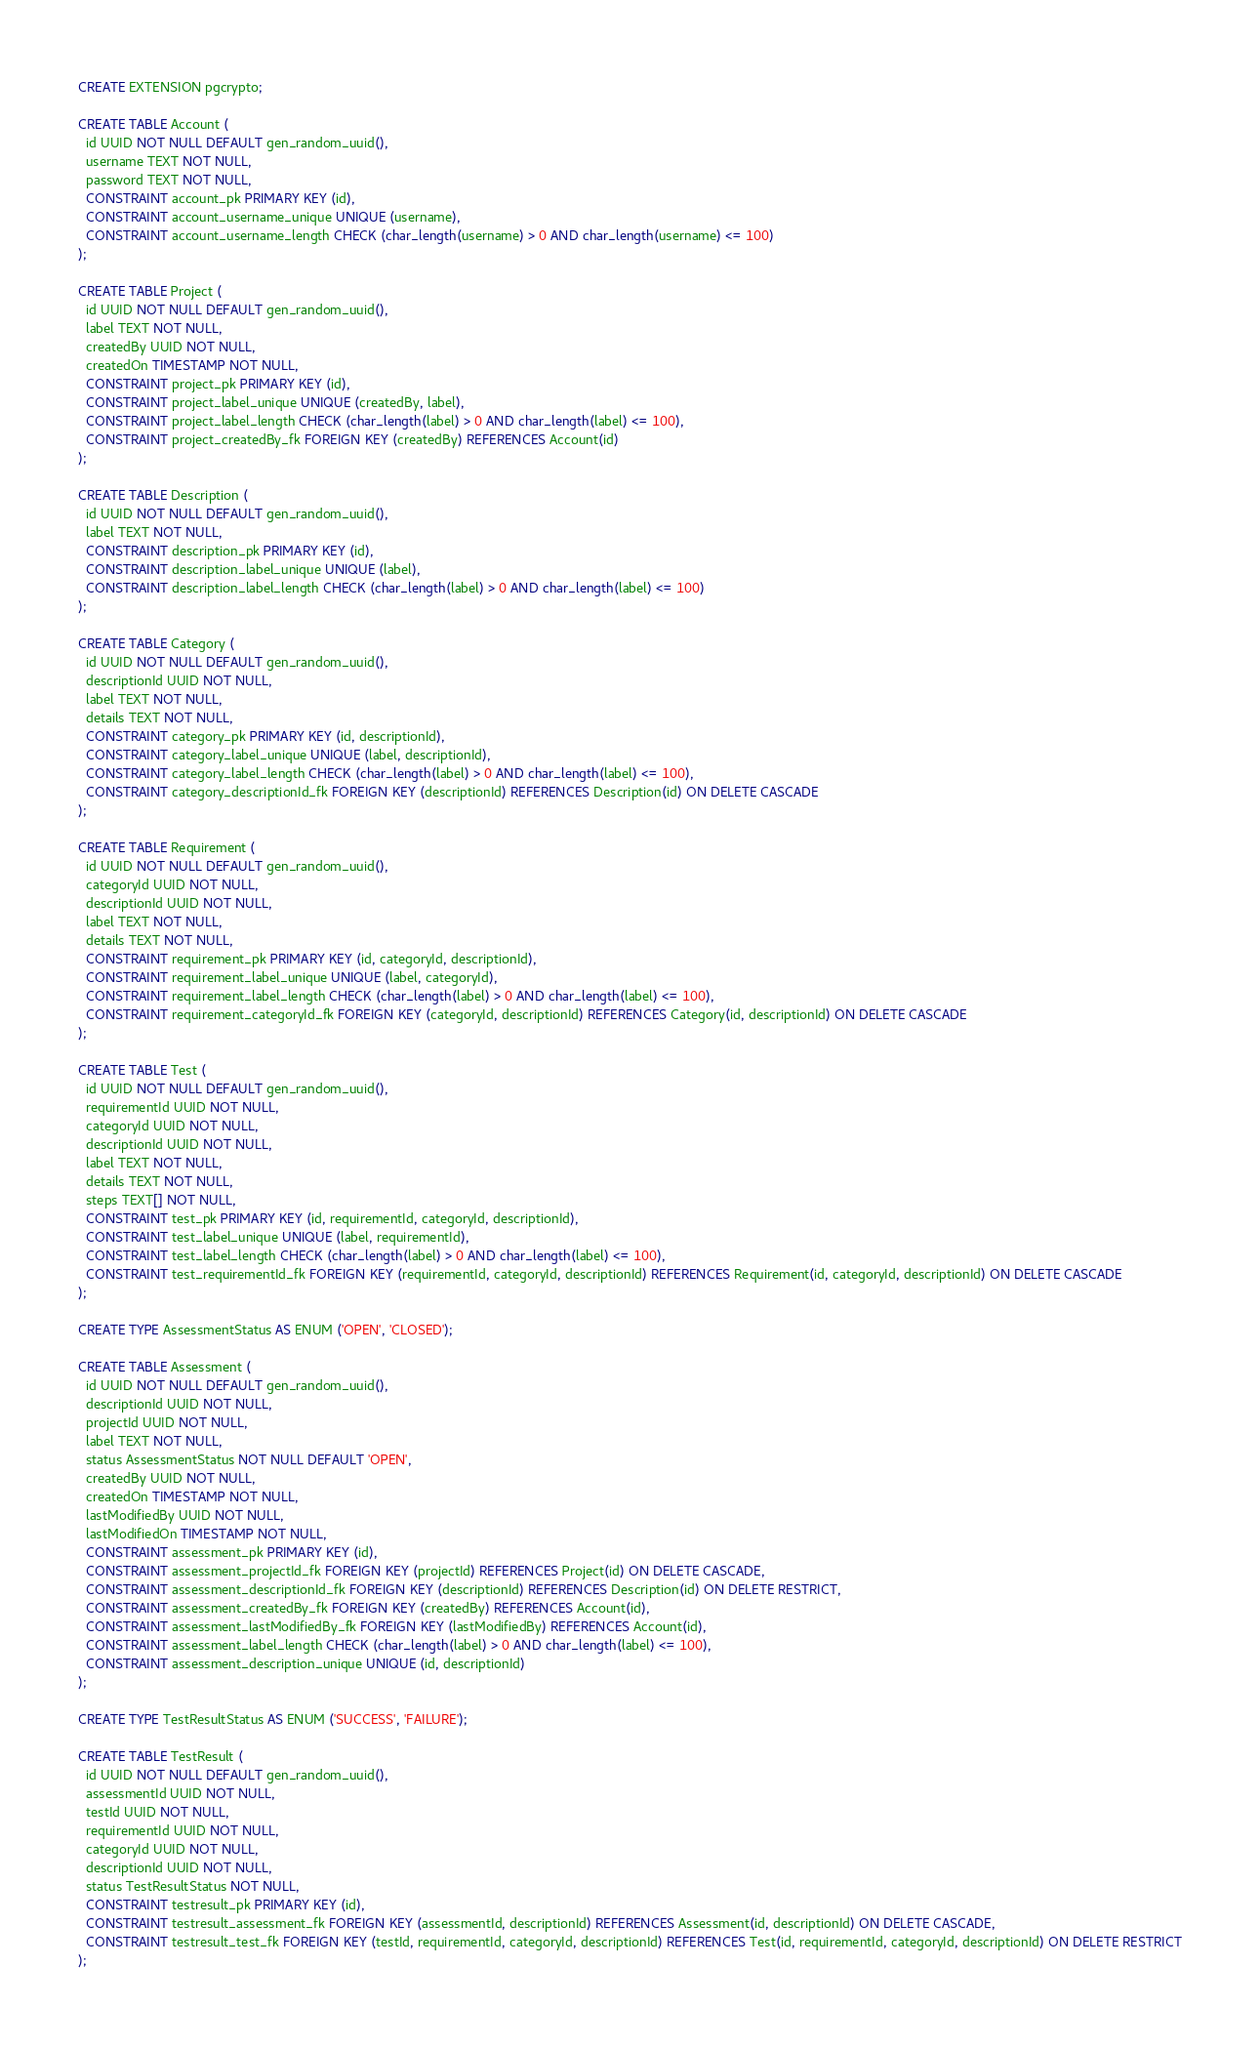Convert code to text. <code><loc_0><loc_0><loc_500><loc_500><_SQL_>CREATE EXTENSION pgcrypto;

CREATE TABLE Account (
  id UUID NOT NULL DEFAULT gen_random_uuid(),
  username TEXT NOT NULL,
  password TEXT NOT NULL,
  CONSTRAINT account_pk PRIMARY KEY (id),
  CONSTRAINT account_username_unique UNIQUE (username),
  CONSTRAINT account_username_length CHECK (char_length(username) > 0 AND char_length(username) <= 100)
);

CREATE TABLE Project (
  id UUID NOT NULL DEFAULT gen_random_uuid(),
  label TEXT NOT NULL,
  createdBy UUID NOT NULL,
  createdOn TIMESTAMP NOT NULL,
  CONSTRAINT project_pk PRIMARY KEY (id),
  CONSTRAINT project_label_unique UNIQUE (createdBy, label),
  CONSTRAINT project_label_length CHECK (char_length(label) > 0 AND char_length(label) <= 100),
  CONSTRAINT project_createdBy_fk FOREIGN KEY (createdBy) REFERENCES Account(id)
);

CREATE TABLE Description (
  id UUID NOT NULL DEFAULT gen_random_uuid(),
  label TEXT NOT NULL,
  CONSTRAINT description_pk PRIMARY KEY (id),
  CONSTRAINT description_label_unique UNIQUE (label),
  CONSTRAINT description_label_length CHECK (char_length(label) > 0 AND char_length(label) <= 100)
);

CREATE TABLE Category (
  id UUID NOT NULL DEFAULT gen_random_uuid(),
  descriptionId UUID NOT NULL,
  label TEXT NOT NULL,
  details TEXT NOT NULL,
  CONSTRAINT category_pk PRIMARY KEY (id, descriptionId),
  CONSTRAINT category_label_unique UNIQUE (label, descriptionId),
  CONSTRAINT category_label_length CHECK (char_length(label) > 0 AND char_length(label) <= 100),
  CONSTRAINT category_descriptionId_fk FOREIGN KEY (descriptionId) REFERENCES Description(id) ON DELETE CASCADE
);

CREATE TABLE Requirement (
  id UUID NOT NULL DEFAULT gen_random_uuid(),
  categoryId UUID NOT NULL,
  descriptionId UUID NOT NULL,
  label TEXT NOT NULL,
  details TEXT NOT NULL,
  CONSTRAINT requirement_pk PRIMARY KEY (id, categoryId, descriptionId),
  CONSTRAINT requirement_label_unique UNIQUE (label, categoryId),
  CONSTRAINT requirement_label_length CHECK (char_length(label) > 0 AND char_length(label) <= 100),
  CONSTRAINT requirement_categoryId_fk FOREIGN KEY (categoryId, descriptionId) REFERENCES Category(id, descriptionId) ON DELETE CASCADE
);

CREATE TABLE Test (
  id UUID NOT NULL DEFAULT gen_random_uuid(),
  requirementId UUID NOT NULL,
  categoryId UUID NOT NULL,
  descriptionId UUID NOT NULL,
  label TEXT NOT NULL,
  details TEXT NOT NULL,
  steps TEXT[] NOT NULL,
  CONSTRAINT test_pk PRIMARY KEY (id, requirementId, categoryId, descriptionId),
  CONSTRAINT test_label_unique UNIQUE (label, requirementId),
  CONSTRAINT test_label_length CHECK (char_length(label) > 0 AND char_length(label) <= 100),
  CONSTRAINT test_requirementId_fk FOREIGN KEY (requirementId, categoryId, descriptionId) REFERENCES Requirement(id, categoryId, descriptionId) ON DELETE CASCADE
);

CREATE TYPE AssessmentStatus AS ENUM ('OPEN', 'CLOSED');

CREATE TABLE Assessment (
  id UUID NOT NULL DEFAULT gen_random_uuid(),
  descriptionId UUID NOT NULL,
  projectId UUID NOT NULL,
  label TEXT NOT NULL,
  status AssessmentStatus NOT NULL DEFAULT 'OPEN',
  createdBy UUID NOT NULL,
  createdOn TIMESTAMP NOT NULL,
  lastModifiedBy UUID NOT NULL,
  lastModifiedOn TIMESTAMP NOT NULL,
  CONSTRAINT assessment_pk PRIMARY KEY (id),
  CONSTRAINT assessment_projectId_fk FOREIGN KEY (projectId) REFERENCES Project(id) ON DELETE CASCADE,
  CONSTRAINT assessment_descriptionId_fk FOREIGN KEY (descriptionId) REFERENCES Description(id) ON DELETE RESTRICT,
  CONSTRAINT assessment_createdBy_fk FOREIGN KEY (createdBy) REFERENCES Account(id),
  CONSTRAINT assessment_lastModifiedBy_fk FOREIGN KEY (lastModifiedBy) REFERENCES Account(id),
  CONSTRAINT assessment_label_length CHECK (char_length(label) > 0 AND char_length(label) <= 100),
  CONSTRAINT assessment_description_unique UNIQUE (id, descriptionId)
);

CREATE TYPE TestResultStatus AS ENUM ('SUCCESS', 'FAILURE');

CREATE TABLE TestResult (
  id UUID NOT NULL DEFAULT gen_random_uuid(),
  assessmentId UUID NOT NULL,
  testId UUID NOT NULL,
  requirementId UUID NOT NULL,
  categoryId UUID NOT NULL,
  descriptionId UUID NOT NULL,
  status TestResultStatus NOT NULL,
  CONSTRAINT testresult_pk PRIMARY KEY (id),
  CONSTRAINT testresult_assessment_fk FOREIGN KEY (assessmentId, descriptionId) REFERENCES Assessment(id, descriptionId) ON DELETE CASCADE,
  CONSTRAINT testresult_test_fk FOREIGN KEY (testId, requirementId, categoryId, descriptionId) REFERENCES Test(id, requirementId, categoryId, descriptionId) ON DELETE RESTRICT
);


</code> 